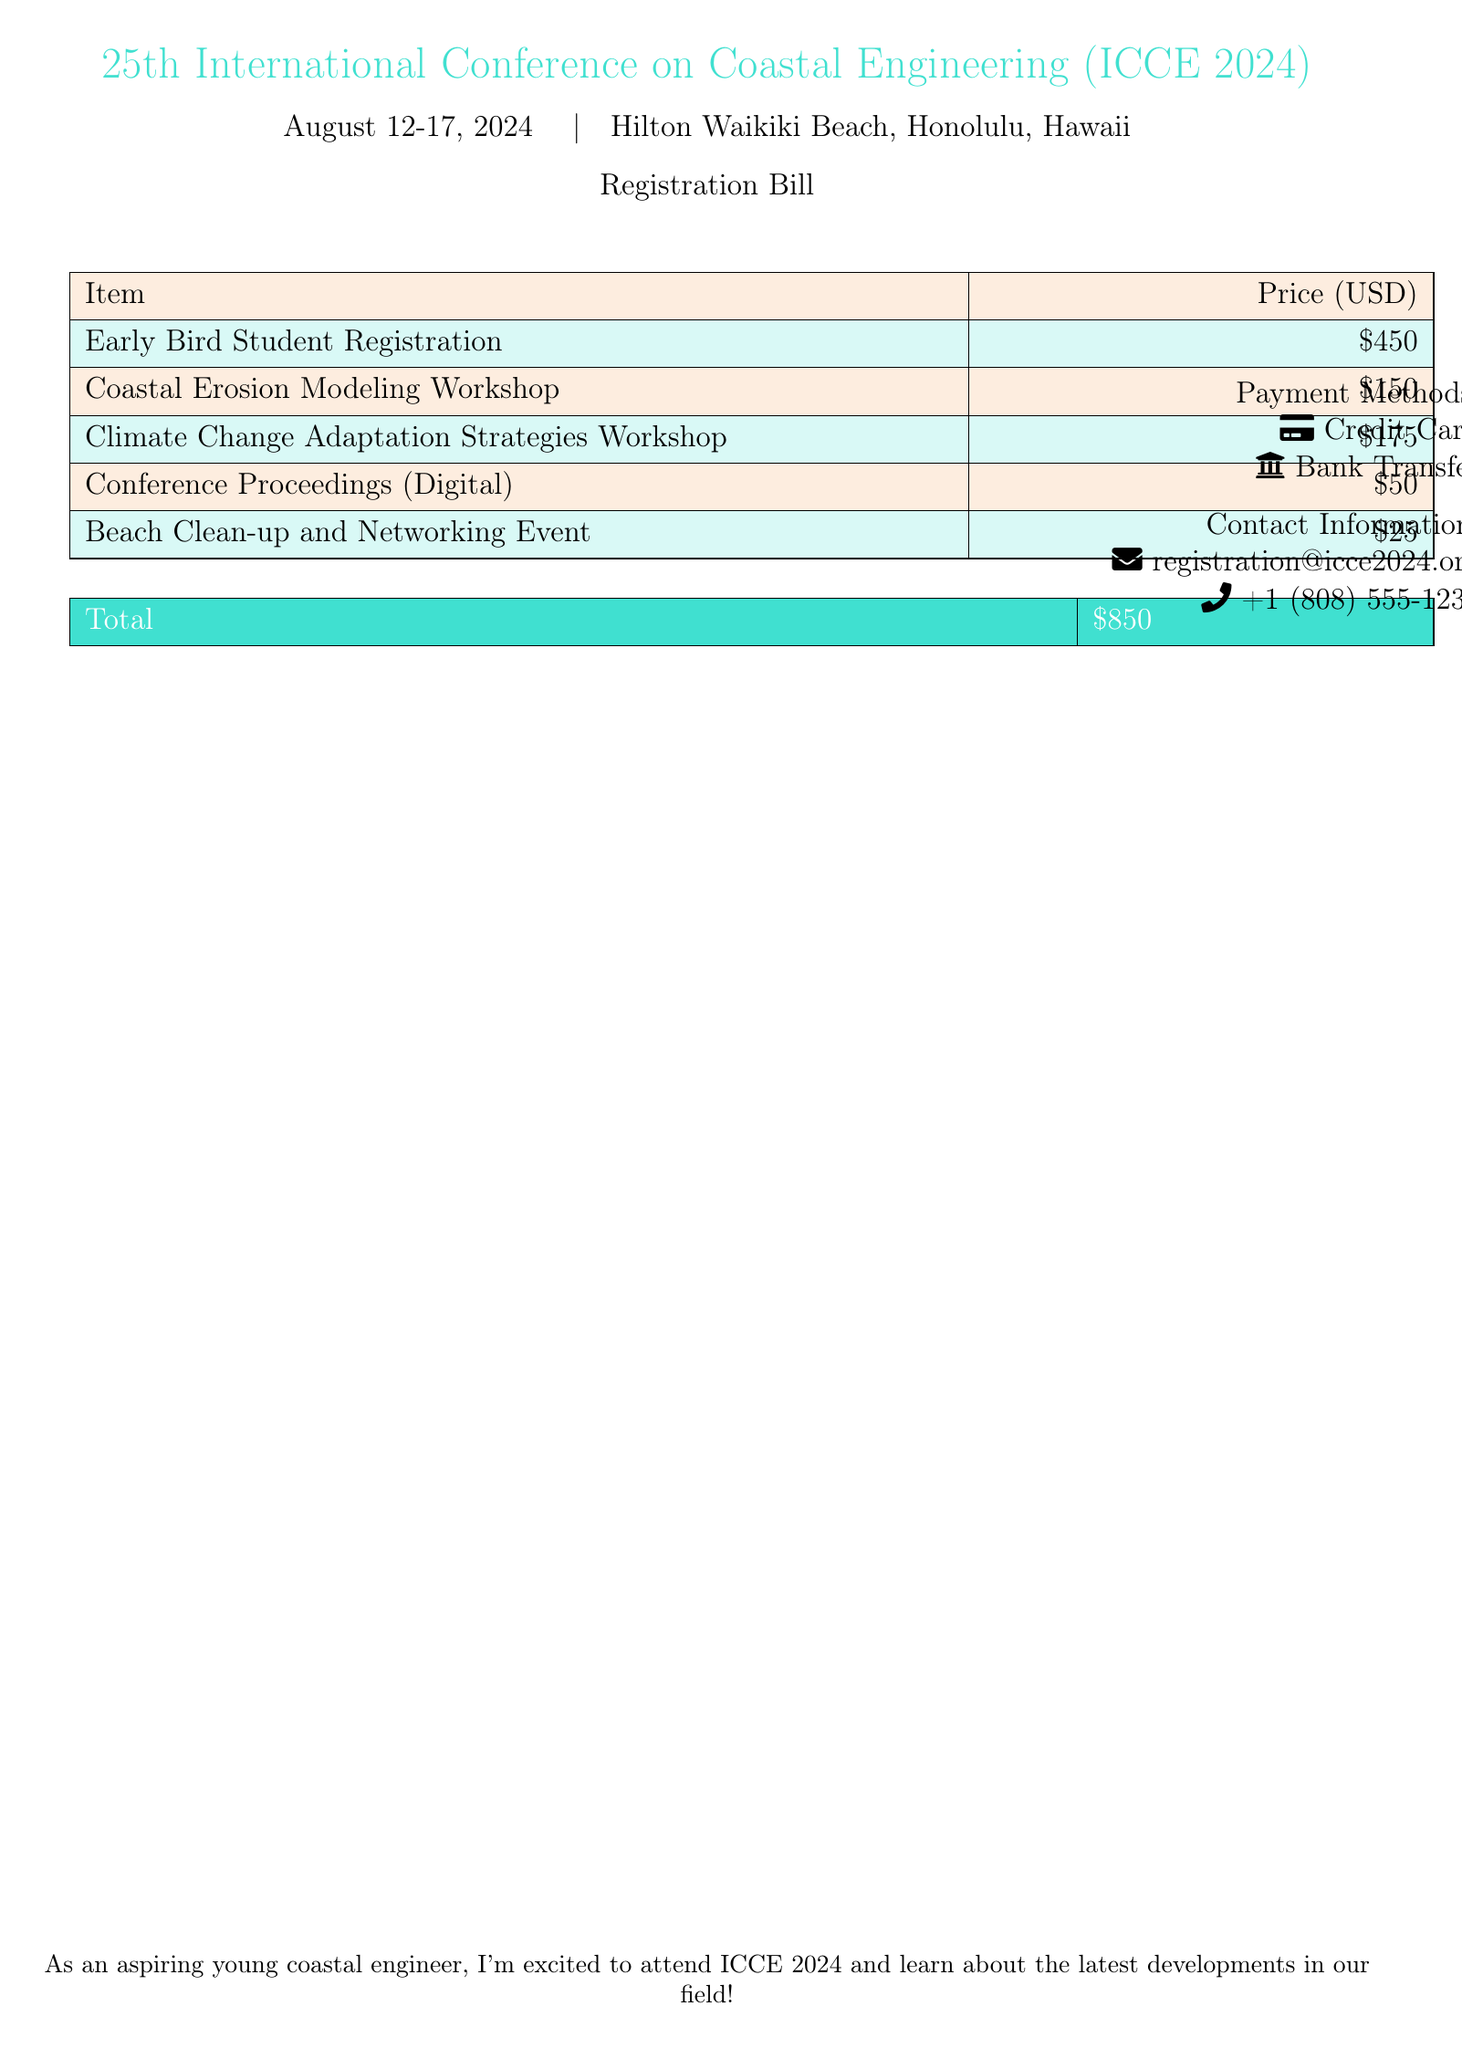What is the date of the conference? The conference is scheduled to take place from August 12 to August 17 in the year 2024.
Answer: August 12-17, 2024 What is the location of the conference? The conference will be held at the Hilton Waikiki Beach in Honolulu, Hawaii.
Answer: Hilton Waikiki Beach, Honolulu, Hawaii What is the price for the Early Bird Student Registration? The document specifies that the price for the Early Bird Student Registration is $450.
Answer: $450 How much does the Climate Change Adaptation Strategies Workshop cost? The fee for the Climate Change Adaptation Strategies Workshop is mentioned as $175 in the document.
Answer: $175 What is the total amount for all services listed? The total for the items in the registration bill adds up to $850 as indicated at the bottom.
Answer: $850 What is included in the registration bill? The registration bill includes several items such as workshops, registration fees, and events as detailed in the table.
Answer: Workshops, registration fees, events What is the fee for the Beach Clean-up and Networking Event? According to the document, the Beach Clean-up and Networking Event costs $25.
Answer: $25 How can one contact for more information about registration? The document provides an email address and phone number for contact regarding registration.
Answer: registration@icce2024.org What payment methods are accepted? The document lists credit card and bank transfer as accepted payment methods.
Answer: Credit Card, Bank Transfer 